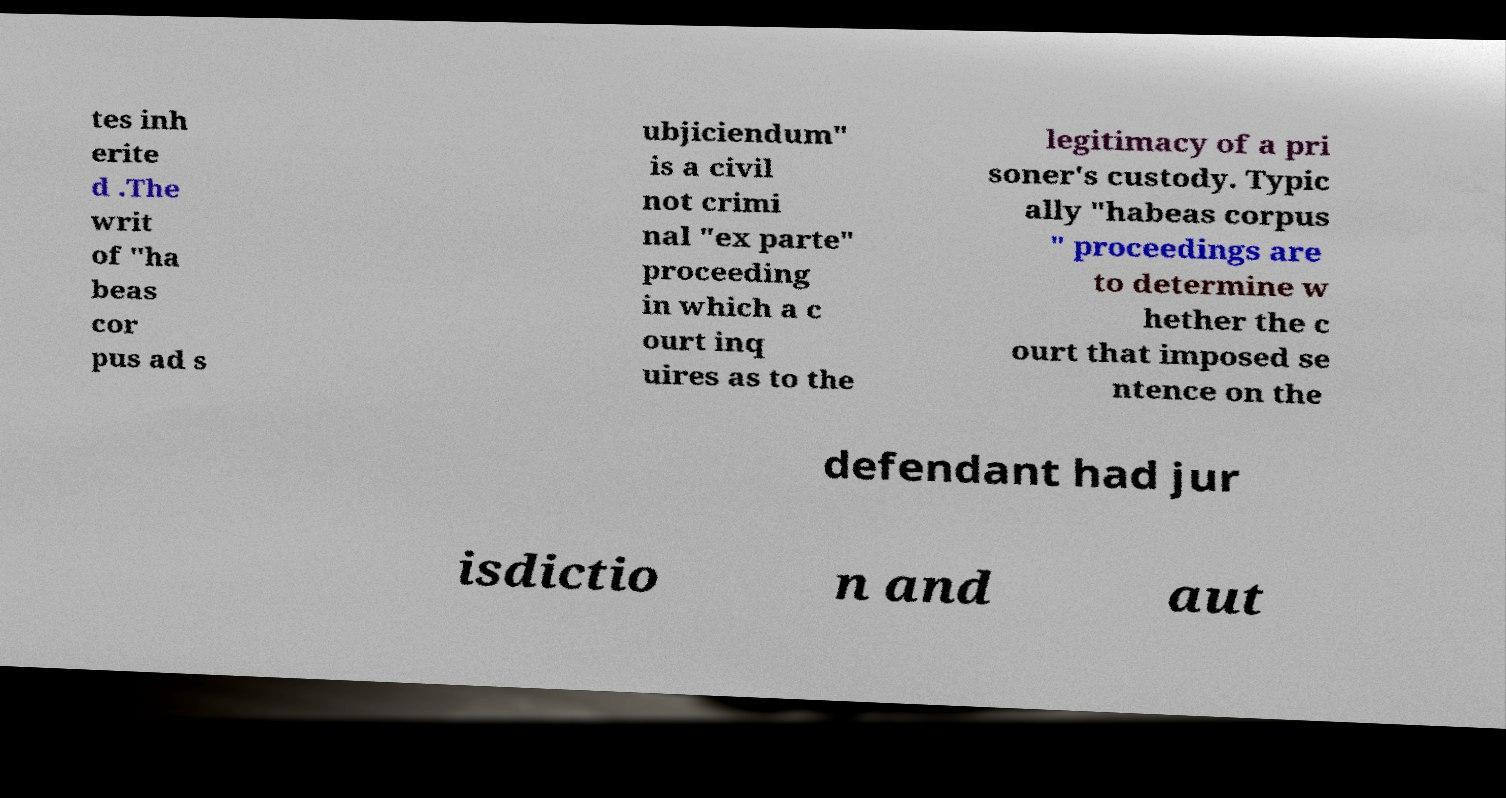What messages or text are displayed in this image? I need them in a readable, typed format. tes inh erite d .The writ of "ha beas cor pus ad s ubjiciendum" is a civil not crimi nal "ex parte" proceeding in which a c ourt inq uires as to the legitimacy of a pri soner's custody. Typic ally "habeas corpus " proceedings are to determine w hether the c ourt that imposed se ntence on the defendant had jur isdictio n and aut 